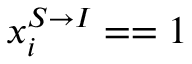Convert formula to latex. <formula><loc_0><loc_0><loc_500><loc_500>x _ { i } ^ { S \rightarrow I } = = 1</formula> 